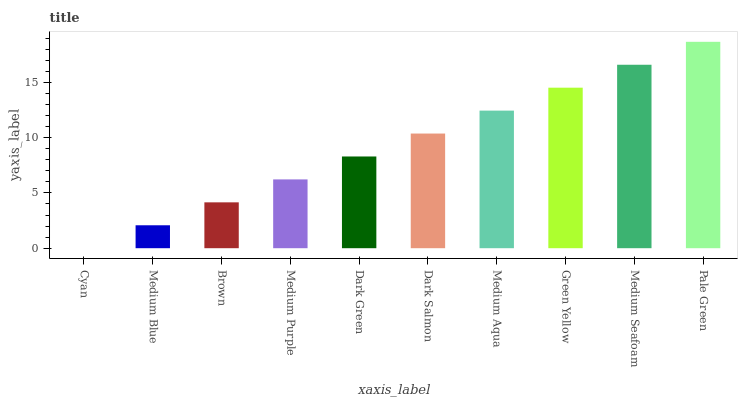Is Cyan the minimum?
Answer yes or no. Yes. Is Pale Green the maximum?
Answer yes or no. Yes. Is Medium Blue the minimum?
Answer yes or no. No. Is Medium Blue the maximum?
Answer yes or no. No. Is Medium Blue greater than Cyan?
Answer yes or no. Yes. Is Cyan less than Medium Blue?
Answer yes or no. Yes. Is Cyan greater than Medium Blue?
Answer yes or no. No. Is Medium Blue less than Cyan?
Answer yes or no. No. Is Dark Salmon the high median?
Answer yes or no. Yes. Is Dark Green the low median?
Answer yes or no. Yes. Is Dark Green the high median?
Answer yes or no. No. Is Medium Blue the low median?
Answer yes or no. No. 